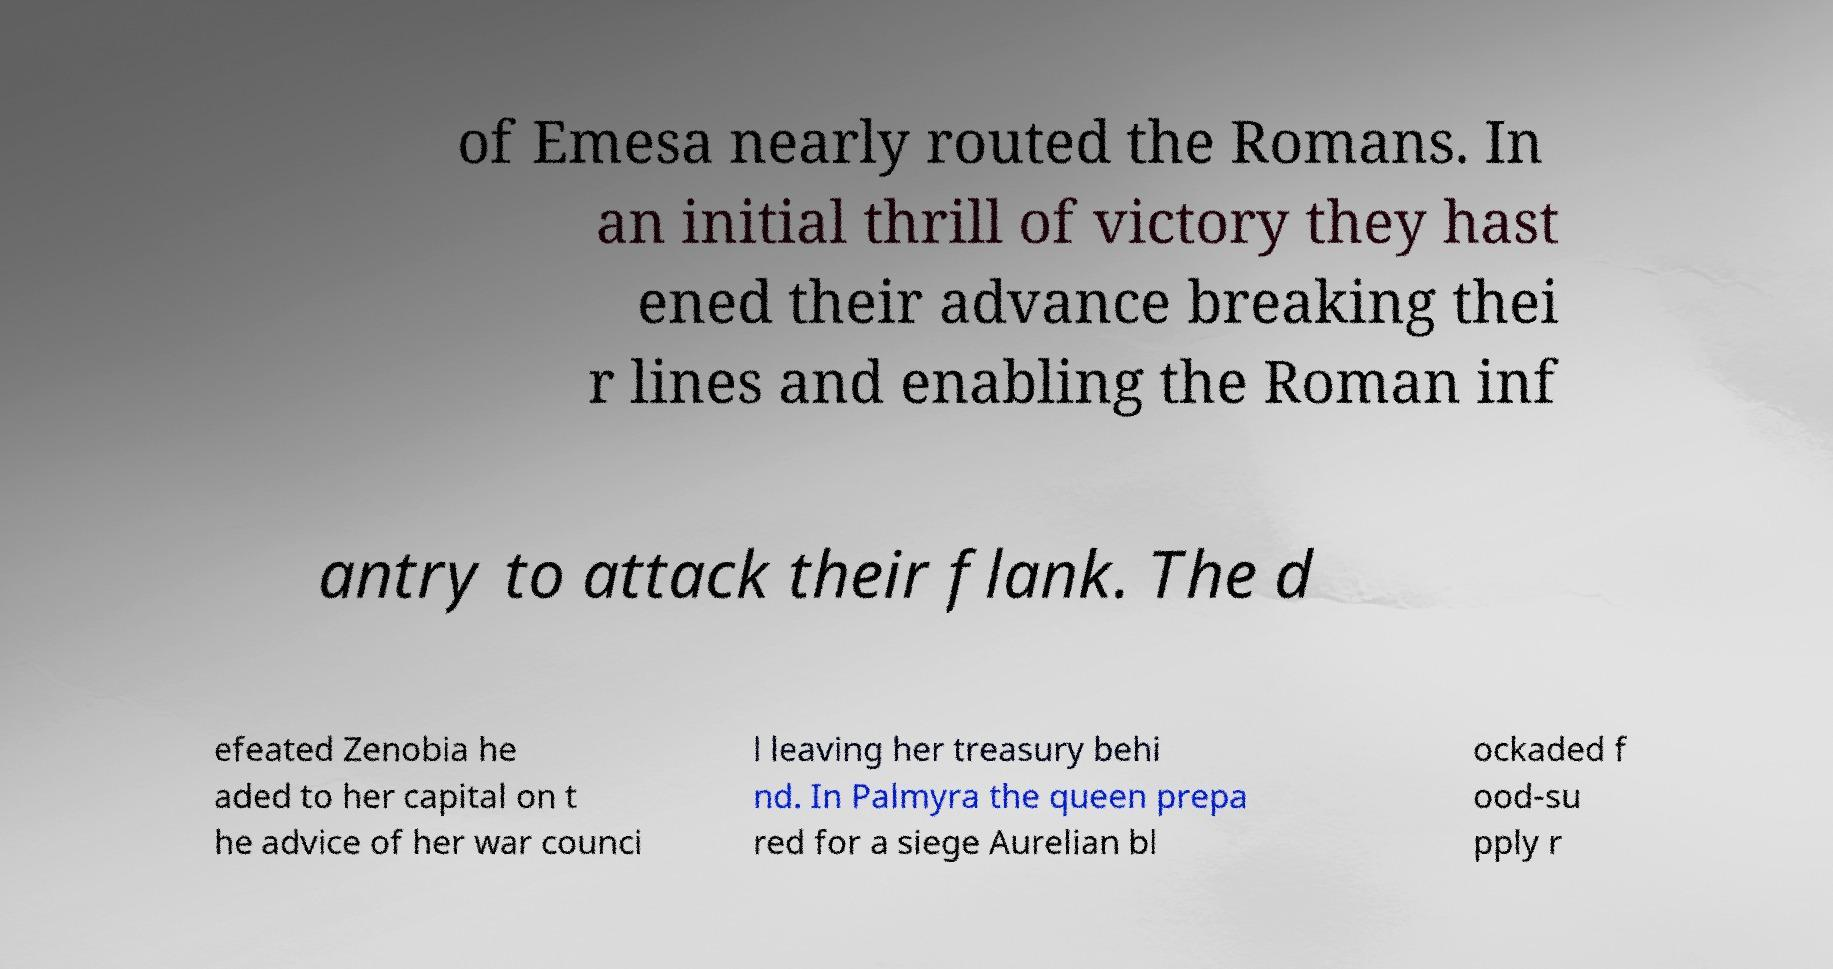Can you accurately transcribe the text from the provided image for me? of Emesa nearly routed the Romans. In an initial thrill of victory they hast ened their advance breaking thei r lines and enabling the Roman inf antry to attack their flank. The d efeated Zenobia he aded to her capital on t he advice of her war counci l leaving her treasury behi nd. In Palmyra the queen prepa red for a siege Aurelian bl ockaded f ood-su pply r 